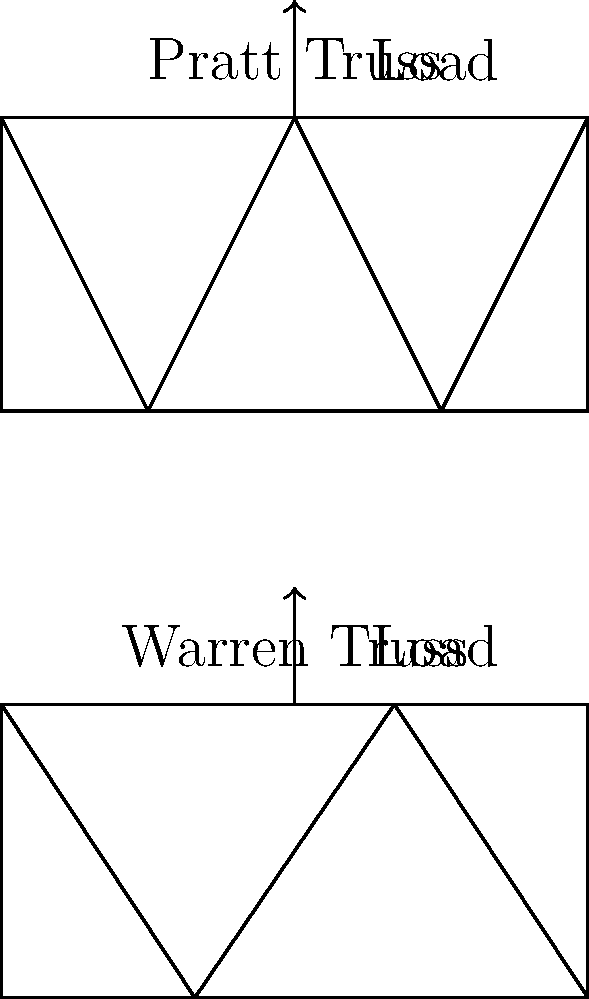As a digital media artist exploring the creative potential of language in bridge design visualization, how would you explain the key difference in load distribution between the Pratt and Warren truss designs shown in the image? To answer this question, let's analyze the load distribution in both truss designs:

1. Pratt Truss:
   - Vertical members are in compression
   - Diagonal members are in tension
   - Load path: $\text{Load} \rightarrow \text{Vertical} \rightarrow \text{Diagonal} \rightarrow \text{Bottom chord}$

2. Warren Truss:
   - Diagonal members alternate between tension and compression
   - No vertical members (except at supports)
   - Load path: $\text{Load} \rightarrow \text{Diagonal} \rightarrow \text{Bottom chord}$

3. Key differences:
   a. Member forces:
      - Pratt: Consistent tension in diagonals, compression in verticals
      - Warren: Alternating tension and compression in diagonals
   
   b. Load transfer:
      - Pratt: More efficient for longer spans due to consistent force distribution
      - Warren: Simpler design, fewer members, but less efficient for longer spans

4. Visualization perspective:
   - Pratt: Emphasize the "flow" of forces from top to bottom
   - Warren: Highlight the alternating pattern of forces in diagonals

5. Language in design:
   - Pratt: "Directed force language" - forces have a clear directional narrative
   - Warren: "Alternating force language" - forces create a rhythmic pattern

The key difference lies in how the load is transferred through the truss members, with the Pratt design offering a more directed force path and the Warren design providing a simpler, alternating force pattern.
Answer: Pratt truss has consistent tension in diagonals and compression in verticals, while Warren truss has alternating tension and compression in diagonals, resulting in different load transfer efficiency and visual force narratives. 